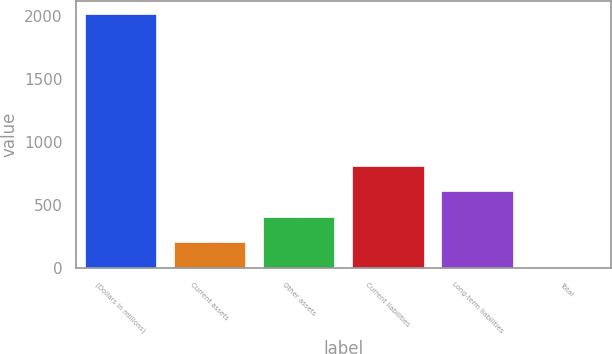<chart> <loc_0><loc_0><loc_500><loc_500><bar_chart><fcel>(Dollars in millions)<fcel>Current assets<fcel>Other assets<fcel>Current liabilities<fcel>Long-term liabilities<fcel>Total<nl><fcel>2014<fcel>204.1<fcel>405.2<fcel>807.4<fcel>606.3<fcel>3<nl></chart> 